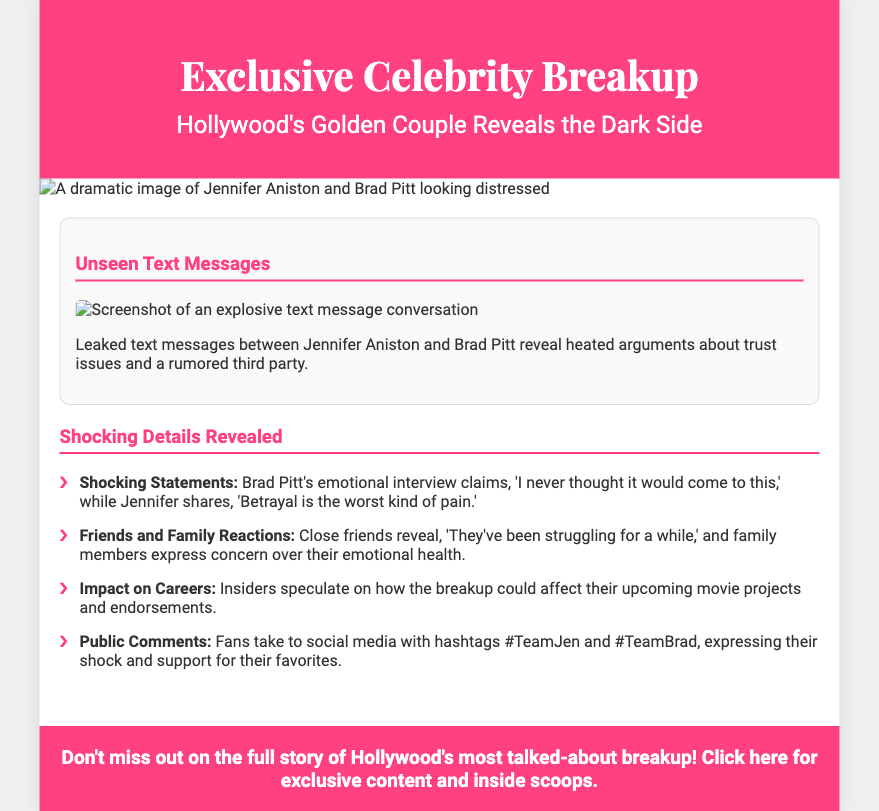what is the title of the poster? The title of the poster is displayed prominently at the top, indicating the main topic.
Answer: Exclusive Celebrity Breakup who are the celebrities involved in the breakup? The text clearly identifies the celebrities that are central to the scandal.
Answer: Jennifer Aniston and Brad Pitt what emotional statement did Brad Pitt make? The document contains a quotation attributed to Brad Pitt that reflects his emotional state regarding the breakup.
Answer: 'I never thought it would come to this' what common concern was expressed by family members? The poster includes a detail about family reactions that highlights their worries.
Answer: Concern over their emotional health what social media hashtags are mentioned? The document mentions public reactions on social media along with specific hashtags used by fans.
Answer: #TeamJen and #TeamBrad what is the main topic of the unseen text messages? The unseen text messages are referenced as revealing key issues between the couple.
Answer: Trust issues and a rumored third party what is the background color of the header? The header's background color is specified in the poster's design details.
Answer: #ff4081 how many key shocking details are listed in the document? The content lists a total of notable shocking details related to the breakup.
Answer: Four 